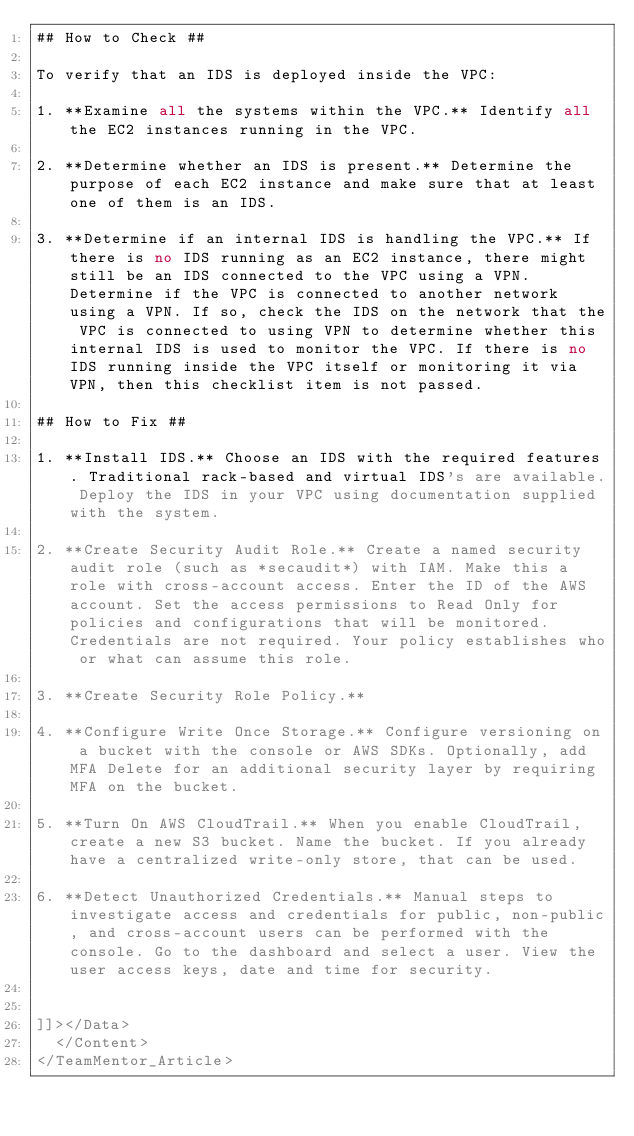<code> <loc_0><loc_0><loc_500><loc_500><_XML_>## How to Check ##

To verify that an IDS is deployed inside the VPC:

1. **Examine all the systems within the VPC.** Identify all the EC2 instances running in the VPC.

2. **Determine whether an IDS is present.** Determine the purpose of each EC2 instance and make sure that at least one of them is an IDS.

3. **Determine if an internal IDS is handling the VPC.** If there is no IDS running as an EC2 instance, there might still be an IDS connected to the VPC using a VPN. Determine if the VPC is connected to another network using a VPN. If so, check the IDS on the network that the VPC is connected to using VPN to determine whether this internal IDS is used to monitor the VPC. If there is no IDS running inside the VPC itself or monitoring it via VPN, then this checklist item is not passed.

## How to Fix ##

1. **Install IDS.** Choose an IDS with the required features. Traditional rack-based and virtual IDS's are available. Deploy the IDS in your VPC using documentation supplied with the system.

2. **Create Security Audit Role.** Create a named security audit role (such as *secaudit*) with IAM. Make this a role with cross-account access. Enter the ID of the AWS account. Set the access permissions to Read Only for policies and configurations that will be monitored. Credentials are not required. Your policy establishes who or what can assume this role.

3. **Create Security Role Policy.** 

4. **Configure Write Once Storage.** Configure versioning on a bucket with the console or AWS SDKs. Optionally, add MFA Delete for an additional security layer by requiring MFA on the bucket.

5. **Turn On AWS CloudTrail.** When you enable CloudTrail, create a new S3 bucket. Name the bucket. If you already have a centralized write-only store, that can be used.

6. **Detect Unauthorized Credentials.** Manual steps to investigate access and credentials for public, non-public, and cross-account users can be performed with the console. Go to the dashboard and select a user. View the user access keys, date and time for security. 


]]></Data>
  </Content>
</TeamMentor_Article></code> 